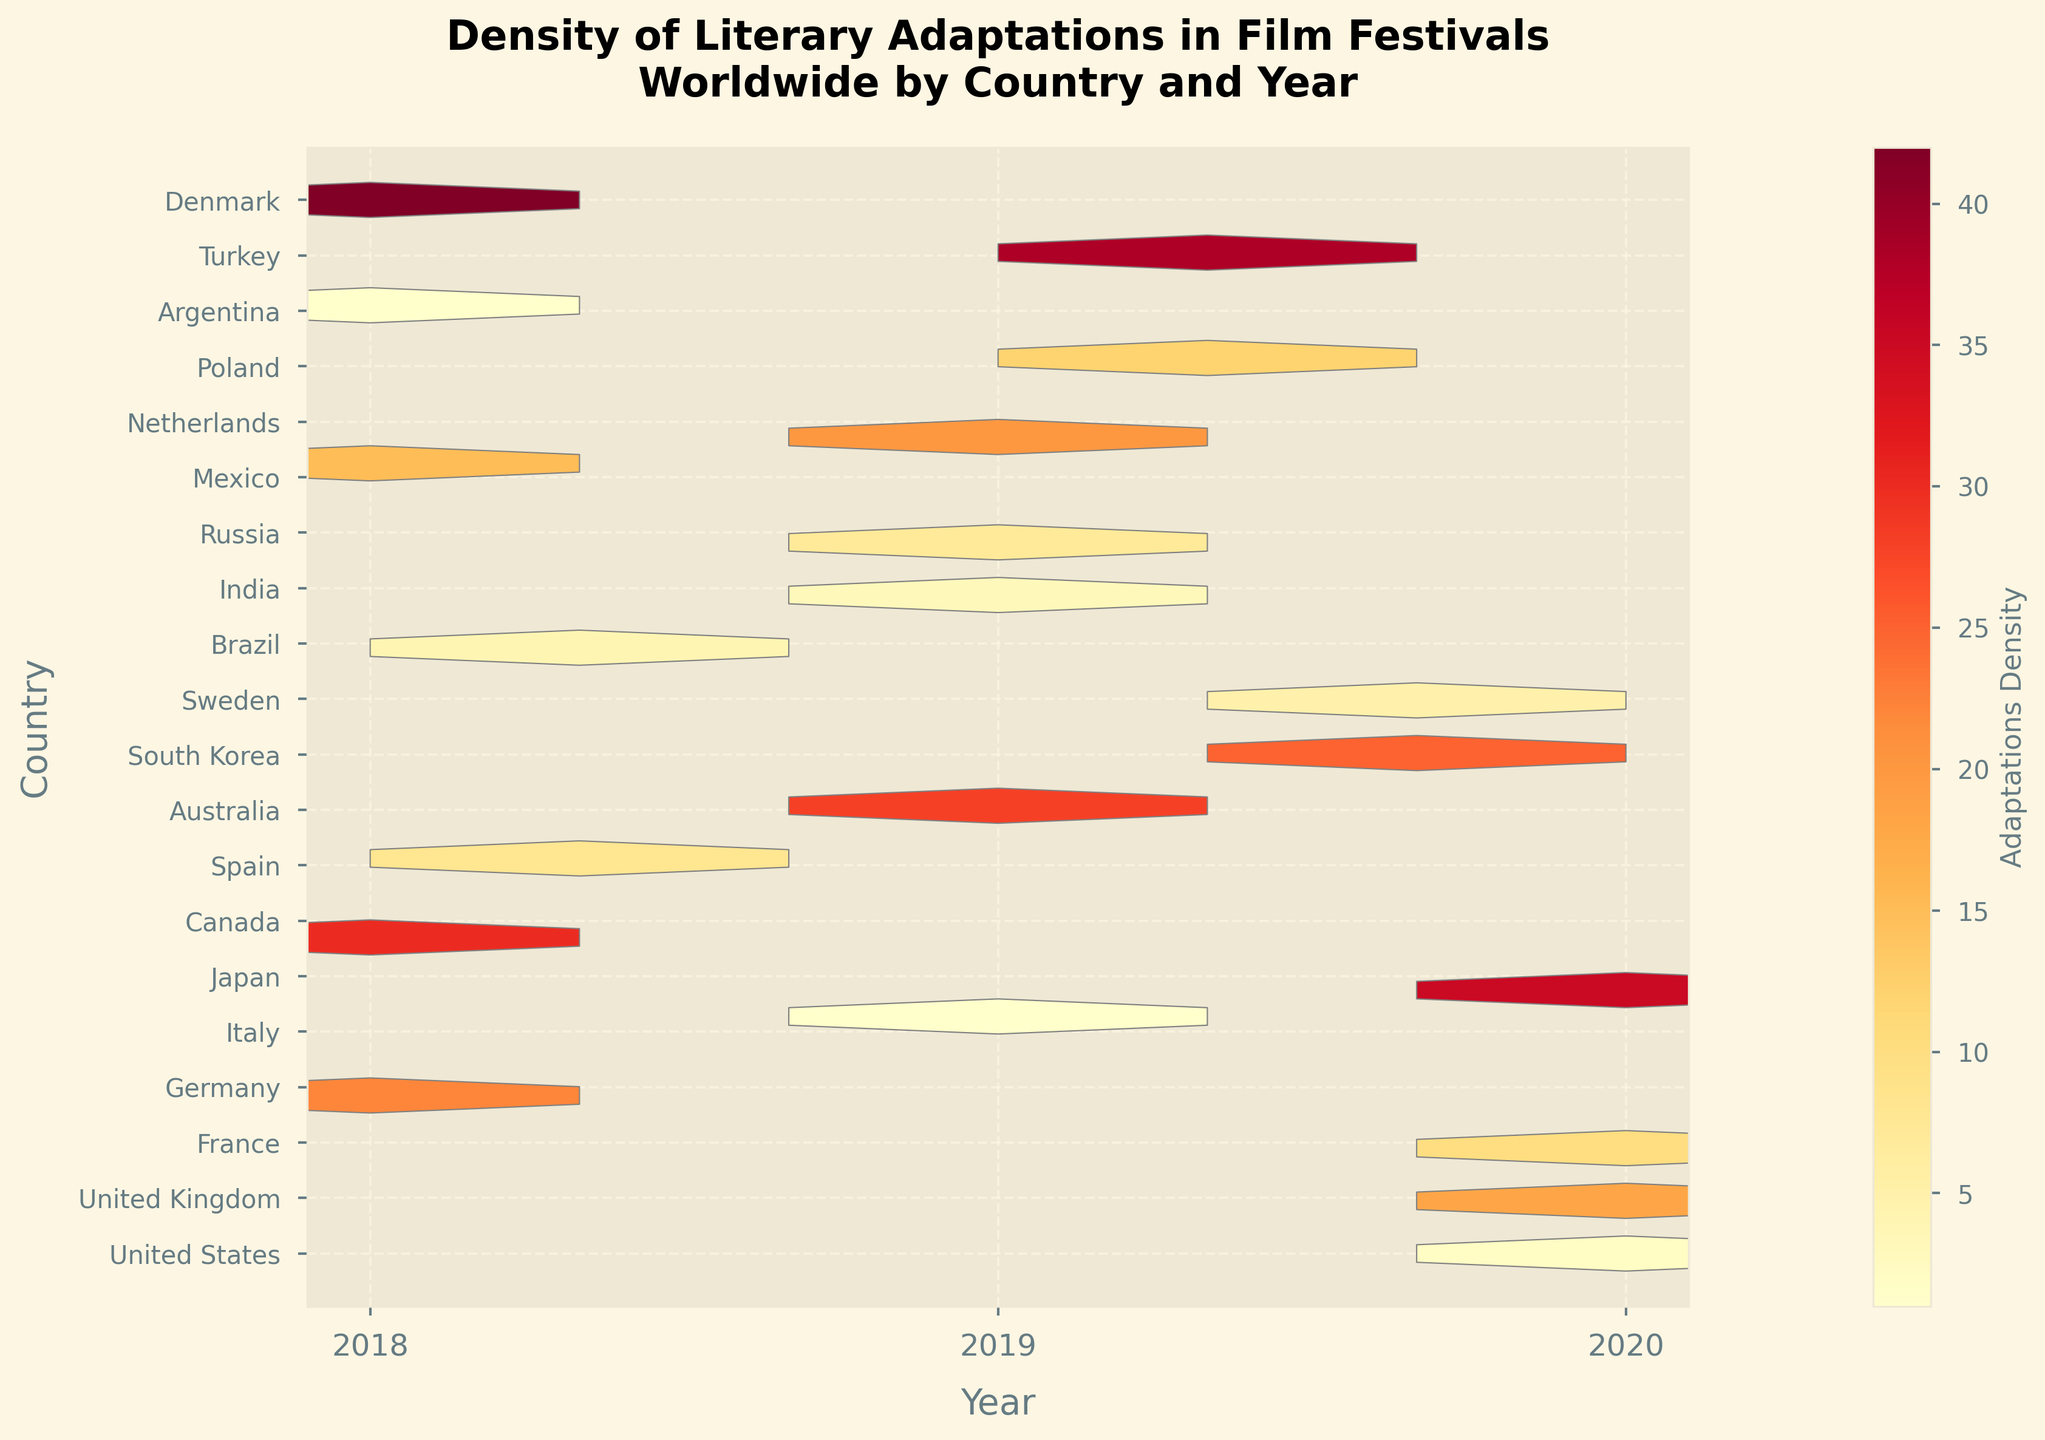What is the title of the figure? The title is typically located at the top of the figure and serves to summarize what the figure is displaying.
Answer: Density of Literary Adaptations in Film Festivals Worldwide by Country and Year Which year has the highest density of literary adaptations? By examining the color intensity and values in the figure for different years, the year with the highest density can be identified.
Answer: 2018 How many years are represented in the hexbin plot? By counting the distinct ticks or labels along the x-axis, the total number of years shown in the hexbin plot can be determined.
Answer: 3 Which country shows the lowest density of literary adaptations in 2020? By looking for the lightest shades or smallest values in the hexbin cells corresponding to the year 2020, the country with the lowest density can be identified.
Answer: Argentina Which countries have an adaptation density greater than 30 in any year? By observing the hexbin cells with darker shades or higher values (above 30) and noting the corresponding countries, we determine these countries.
Answer: United States, United Kingdom, France, Germany Compare the density of literary adaptations in 2018 and 2019 for the United Kingdom. Find the hexbin cells corresponding to the United Kingdom for 2018 and 2019 and compare their color intensities or values.
Answer: Higher in 2019 How does Japan’s adaptation density in 2020 compare to Canada’s in 2018? Check the hexbin cells corresponding to Japan in 2020 and Canada in 2018, and compare their shades or values.
Answer: Japan's is higher Is there a country with constant adaptation density over the years shown? Look for a country with hexbin cells having the same color intensity or value across all represented years.
Answer: No What's the total number of countries represented in the plot? Count the distinct ticks or labels along the y-axis, which represent the countries included in the plot.
Answer: 18 What is the average density of literary adaptations in 2020 for all countries? Locate the hexbin cells for the year 2020, sum their densities, and divide by the number of countries for that year. Step-by-step: (35 + 25 + 18 + 10 + 5 + 2) = 95, and there are 6 countries in 2020. Thus, the average is 95/6 ≈ 15.83.
Answer: 15.83 